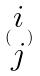Convert formula to latex. <formula><loc_0><loc_0><loc_500><loc_500>( \begin{matrix} i \\ j \end{matrix} )</formula> 